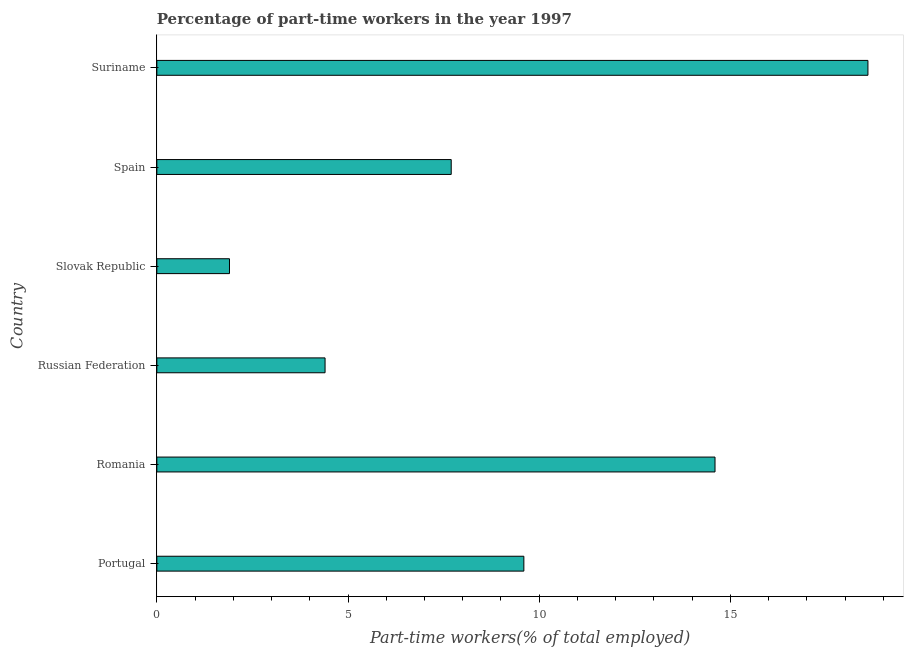Does the graph contain any zero values?
Your answer should be very brief. No. Does the graph contain grids?
Give a very brief answer. No. What is the title of the graph?
Offer a very short reply. Percentage of part-time workers in the year 1997. What is the label or title of the X-axis?
Make the answer very short. Part-time workers(% of total employed). What is the label or title of the Y-axis?
Your answer should be compact. Country. What is the percentage of part-time workers in Spain?
Provide a succinct answer. 7.7. Across all countries, what is the maximum percentage of part-time workers?
Your answer should be very brief. 18.6. Across all countries, what is the minimum percentage of part-time workers?
Keep it short and to the point. 1.9. In which country was the percentage of part-time workers maximum?
Offer a terse response. Suriname. In which country was the percentage of part-time workers minimum?
Keep it short and to the point. Slovak Republic. What is the sum of the percentage of part-time workers?
Ensure brevity in your answer.  56.8. What is the average percentage of part-time workers per country?
Your answer should be compact. 9.47. What is the median percentage of part-time workers?
Ensure brevity in your answer.  8.65. What is the ratio of the percentage of part-time workers in Portugal to that in Slovak Republic?
Your answer should be very brief. 5.05. Is the sum of the percentage of part-time workers in Slovak Republic and Spain greater than the maximum percentage of part-time workers across all countries?
Keep it short and to the point. No. What is the difference between the highest and the lowest percentage of part-time workers?
Provide a short and direct response. 16.7. In how many countries, is the percentage of part-time workers greater than the average percentage of part-time workers taken over all countries?
Ensure brevity in your answer.  3. How many bars are there?
Offer a very short reply. 6. Are all the bars in the graph horizontal?
Provide a short and direct response. Yes. What is the difference between two consecutive major ticks on the X-axis?
Your response must be concise. 5. Are the values on the major ticks of X-axis written in scientific E-notation?
Keep it short and to the point. No. What is the Part-time workers(% of total employed) of Portugal?
Keep it short and to the point. 9.6. What is the Part-time workers(% of total employed) in Romania?
Provide a short and direct response. 14.6. What is the Part-time workers(% of total employed) of Russian Federation?
Make the answer very short. 4.4. What is the Part-time workers(% of total employed) in Slovak Republic?
Ensure brevity in your answer.  1.9. What is the Part-time workers(% of total employed) of Spain?
Provide a succinct answer. 7.7. What is the Part-time workers(% of total employed) in Suriname?
Offer a terse response. 18.6. What is the difference between the Part-time workers(% of total employed) in Portugal and Suriname?
Offer a terse response. -9. What is the difference between the Part-time workers(% of total employed) in Romania and Slovak Republic?
Provide a short and direct response. 12.7. What is the difference between the Part-time workers(% of total employed) in Romania and Suriname?
Your answer should be compact. -4. What is the difference between the Part-time workers(% of total employed) in Russian Federation and Slovak Republic?
Your response must be concise. 2.5. What is the difference between the Part-time workers(% of total employed) in Russian Federation and Spain?
Ensure brevity in your answer.  -3.3. What is the difference between the Part-time workers(% of total employed) in Russian Federation and Suriname?
Provide a short and direct response. -14.2. What is the difference between the Part-time workers(% of total employed) in Slovak Republic and Spain?
Provide a succinct answer. -5.8. What is the difference between the Part-time workers(% of total employed) in Slovak Republic and Suriname?
Offer a very short reply. -16.7. What is the difference between the Part-time workers(% of total employed) in Spain and Suriname?
Offer a very short reply. -10.9. What is the ratio of the Part-time workers(% of total employed) in Portugal to that in Romania?
Your answer should be very brief. 0.66. What is the ratio of the Part-time workers(% of total employed) in Portugal to that in Russian Federation?
Give a very brief answer. 2.18. What is the ratio of the Part-time workers(% of total employed) in Portugal to that in Slovak Republic?
Provide a succinct answer. 5.05. What is the ratio of the Part-time workers(% of total employed) in Portugal to that in Spain?
Your response must be concise. 1.25. What is the ratio of the Part-time workers(% of total employed) in Portugal to that in Suriname?
Ensure brevity in your answer.  0.52. What is the ratio of the Part-time workers(% of total employed) in Romania to that in Russian Federation?
Ensure brevity in your answer.  3.32. What is the ratio of the Part-time workers(% of total employed) in Romania to that in Slovak Republic?
Offer a terse response. 7.68. What is the ratio of the Part-time workers(% of total employed) in Romania to that in Spain?
Your answer should be compact. 1.9. What is the ratio of the Part-time workers(% of total employed) in Romania to that in Suriname?
Give a very brief answer. 0.79. What is the ratio of the Part-time workers(% of total employed) in Russian Federation to that in Slovak Republic?
Offer a terse response. 2.32. What is the ratio of the Part-time workers(% of total employed) in Russian Federation to that in Spain?
Give a very brief answer. 0.57. What is the ratio of the Part-time workers(% of total employed) in Russian Federation to that in Suriname?
Provide a short and direct response. 0.24. What is the ratio of the Part-time workers(% of total employed) in Slovak Republic to that in Spain?
Provide a succinct answer. 0.25. What is the ratio of the Part-time workers(% of total employed) in Slovak Republic to that in Suriname?
Keep it short and to the point. 0.1. What is the ratio of the Part-time workers(% of total employed) in Spain to that in Suriname?
Offer a terse response. 0.41. 